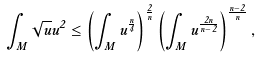Convert formula to latex. <formula><loc_0><loc_0><loc_500><loc_500>\int _ { M } \sqrt { u } u ^ { 2 } \leq \left ( \int _ { M } u ^ { \frac { n } { 4 } } \right ) ^ { \frac { 2 } { n } } \left ( \int _ { M } u ^ { \frac { 2 n } { n - 2 } } \right ) ^ { \frac { n - 2 } n } ,</formula> 